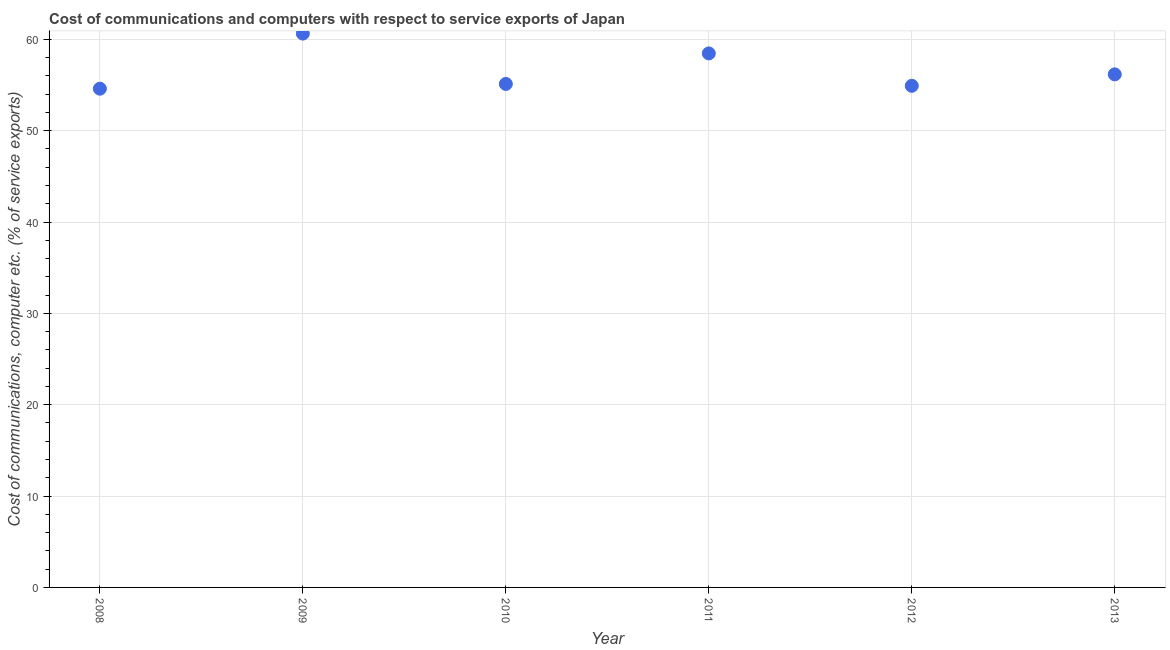What is the cost of communications and computer in 2012?
Provide a succinct answer. 54.91. Across all years, what is the maximum cost of communications and computer?
Give a very brief answer. 60.63. Across all years, what is the minimum cost of communications and computer?
Your response must be concise. 54.6. In which year was the cost of communications and computer minimum?
Your answer should be very brief. 2008. What is the sum of the cost of communications and computer?
Keep it short and to the point. 339.88. What is the difference between the cost of communications and computer in 2008 and 2011?
Offer a very short reply. -3.86. What is the average cost of communications and computer per year?
Provide a short and direct response. 56.65. What is the median cost of communications and computer?
Your answer should be very brief. 55.64. In how many years, is the cost of communications and computer greater than 44 %?
Offer a very short reply. 6. Do a majority of the years between 2012 and 2011 (inclusive) have cost of communications and computer greater than 16 %?
Offer a very short reply. No. What is the ratio of the cost of communications and computer in 2008 to that in 2012?
Keep it short and to the point. 0.99. Is the difference between the cost of communications and computer in 2011 and 2013 greater than the difference between any two years?
Keep it short and to the point. No. What is the difference between the highest and the second highest cost of communications and computer?
Provide a short and direct response. 2.17. Is the sum of the cost of communications and computer in 2012 and 2013 greater than the maximum cost of communications and computer across all years?
Your answer should be very brief. Yes. What is the difference between the highest and the lowest cost of communications and computer?
Your answer should be very brief. 6.03. In how many years, is the cost of communications and computer greater than the average cost of communications and computer taken over all years?
Provide a succinct answer. 2. How many dotlines are there?
Provide a succinct answer. 1. Does the graph contain any zero values?
Provide a succinct answer. No. What is the title of the graph?
Your answer should be compact. Cost of communications and computers with respect to service exports of Japan. What is the label or title of the X-axis?
Your answer should be very brief. Year. What is the label or title of the Y-axis?
Offer a very short reply. Cost of communications, computer etc. (% of service exports). What is the Cost of communications, computer etc. (% of service exports) in 2008?
Offer a terse response. 54.6. What is the Cost of communications, computer etc. (% of service exports) in 2009?
Your response must be concise. 60.63. What is the Cost of communications, computer etc. (% of service exports) in 2010?
Offer a terse response. 55.12. What is the Cost of communications, computer etc. (% of service exports) in 2011?
Provide a short and direct response. 58.46. What is the Cost of communications, computer etc. (% of service exports) in 2012?
Your response must be concise. 54.91. What is the Cost of communications, computer etc. (% of service exports) in 2013?
Ensure brevity in your answer.  56.17. What is the difference between the Cost of communications, computer etc. (% of service exports) in 2008 and 2009?
Keep it short and to the point. -6.03. What is the difference between the Cost of communications, computer etc. (% of service exports) in 2008 and 2010?
Offer a terse response. -0.52. What is the difference between the Cost of communications, computer etc. (% of service exports) in 2008 and 2011?
Ensure brevity in your answer.  -3.86. What is the difference between the Cost of communications, computer etc. (% of service exports) in 2008 and 2012?
Provide a short and direct response. -0.31. What is the difference between the Cost of communications, computer etc. (% of service exports) in 2008 and 2013?
Offer a very short reply. -1.57. What is the difference between the Cost of communications, computer etc. (% of service exports) in 2009 and 2010?
Provide a short and direct response. 5.51. What is the difference between the Cost of communications, computer etc. (% of service exports) in 2009 and 2011?
Keep it short and to the point. 2.17. What is the difference between the Cost of communications, computer etc. (% of service exports) in 2009 and 2012?
Your answer should be compact. 5.72. What is the difference between the Cost of communications, computer etc. (% of service exports) in 2009 and 2013?
Your answer should be compact. 4.46. What is the difference between the Cost of communications, computer etc. (% of service exports) in 2010 and 2011?
Provide a short and direct response. -3.34. What is the difference between the Cost of communications, computer etc. (% of service exports) in 2010 and 2012?
Keep it short and to the point. 0.2. What is the difference between the Cost of communications, computer etc. (% of service exports) in 2010 and 2013?
Provide a succinct answer. -1.05. What is the difference between the Cost of communications, computer etc. (% of service exports) in 2011 and 2012?
Your response must be concise. 3.55. What is the difference between the Cost of communications, computer etc. (% of service exports) in 2011 and 2013?
Your answer should be very brief. 2.29. What is the difference between the Cost of communications, computer etc. (% of service exports) in 2012 and 2013?
Your answer should be very brief. -1.25. What is the ratio of the Cost of communications, computer etc. (% of service exports) in 2008 to that in 2009?
Offer a terse response. 0.9. What is the ratio of the Cost of communications, computer etc. (% of service exports) in 2008 to that in 2010?
Make the answer very short. 0.99. What is the ratio of the Cost of communications, computer etc. (% of service exports) in 2008 to that in 2011?
Make the answer very short. 0.93. What is the ratio of the Cost of communications, computer etc. (% of service exports) in 2008 to that in 2012?
Your answer should be very brief. 0.99. What is the ratio of the Cost of communications, computer etc. (% of service exports) in 2009 to that in 2010?
Your response must be concise. 1.1. What is the ratio of the Cost of communications, computer etc. (% of service exports) in 2009 to that in 2011?
Give a very brief answer. 1.04. What is the ratio of the Cost of communications, computer etc. (% of service exports) in 2009 to that in 2012?
Your answer should be compact. 1.1. What is the ratio of the Cost of communications, computer etc. (% of service exports) in 2009 to that in 2013?
Provide a short and direct response. 1.08. What is the ratio of the Cost of communications, computer etc. (% of service exports) in 2010 to that in 2011?
Make the answer very short. 0.94. What is the ratio of the Cost of communications, computer etc. (% of service exports) in 2010 to that in 2012?
Ensure brevity in your answer.  1. What is the ratio of the Cost of communications, computer etc. (% of service exports) in 2011 to that in 2012?
Make the answer very short. 1.06. What is the ratio of the Cost of communications, computer etc. (% of service exports) in 2011 to that in 2013?
Ensure brevity in your answer.  1.04. What is the ratio of the Cost of communications, computer etc. (% of service exports) in 2012 to that in 2013?
Your answer should be compact. 0.98. 